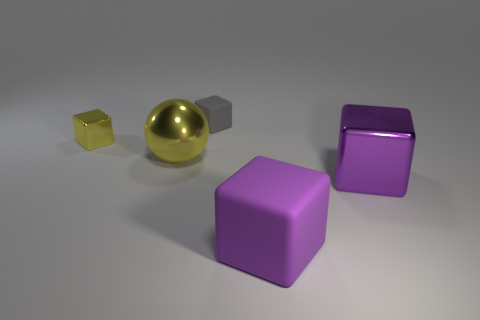Subtract all large metal cubes. How many cubes are left? 3 Subtract all yellow blocks. How many blocks are left? 3 Subtract all brown blocks. Subtract all yellow cylinders. How many blocks are left? 4 Add 2 tiny matte blocks. How many objects exist? 7 Subtract all balls. How many objects are left? 4 Subtract 0 purple spheres. How many objects are left? 5 Subtract all large purple matte cylinders. Subtract all shiny blocks. How many objects are left? 3 Add 5 rubber objects. How many rubber objects are left? 7 Add 2 big objects. How many big objects exist? 5 